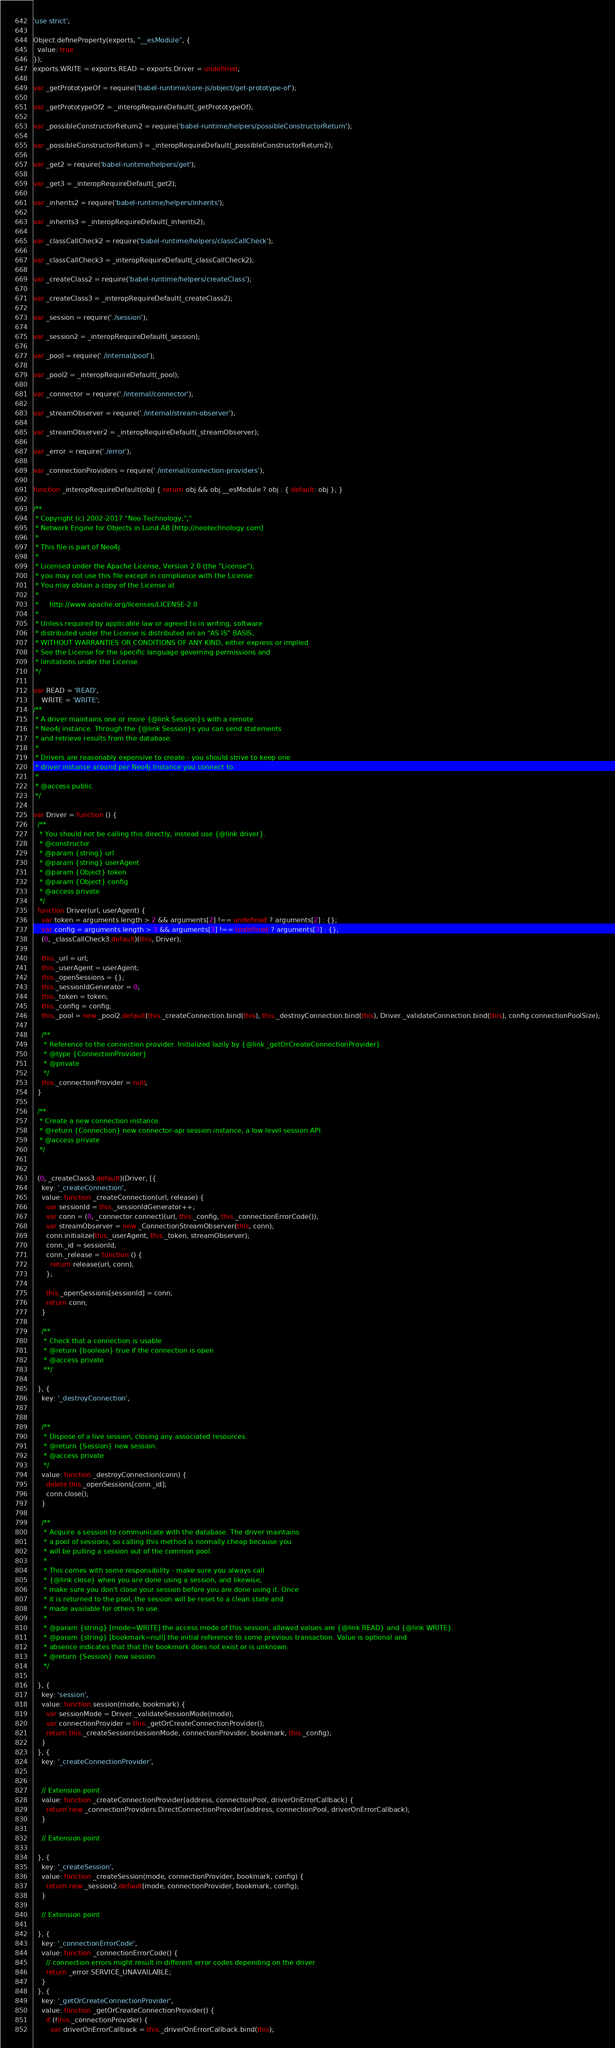Convert code to text. <code><loc_0><loc_0><loc_500><loc_500><_JavaScript_>'use strict';

Object.defineProperty(exports, "__esModule", {
  value: true
});
exports.WRITE = exports.READ = exports.Driver = undefined;

var _getPrototypeOf = require('babel-runtime/core-js/object/get-prototype-of');

var _getPrototypeOf2 = _interopRequireDefault(_getPrototypeOf);

var _possibleConstructorReturn2 = require('babel-runtime/helpers/possibleConstructorReturn');

var _possibleConstructorReturn3 = _interopRequireDefault(_possibleConstructorReturn2);

var _get2 = require('babel-runtime/helpers/get');

var _get3 = _interopRequireDefault(_get2);

var _inherits2 = require('babel-runtime/helpers/inherits');

var _inherits3 = _interopRequireDefault(_inherits2);

var _classCallCheck2 = require('babel-runtime/helpers/classCallCheck');

var _classCallCheck3 = _interopRequireDefault(_classCallCheck2);

var _createClass2 = require('babel-runtime/helpers/createClass');

var _createClass3 = _interopRequireDefault(_createClass2);

var _session = require('./session');

var _session2 = _interopRequireDefault(_session);

var _pool = require('./internal/pool');

var _pool2 = _interopRequireDefault(_pool);

var _connector = require('./internal/connector');

var _streamObserver = require('./internal/stream-observer');

var _streamObserver2 = _interopRequireDefault(_streamObserver);

var _error = require('./error');

var _connectionProviders = require('./internal/connection-providers');

function _interopRequireDefault(obj) { return obj && obj.__esModule ? obj : { default: obj }; }

/**
 * Copyright (c) 2002-2017 "Neo Technology,","
 * Network Engine for Objects in Lund AB [http://neotechnology.com]
 *
 * This file is part of Neo4j.
 *
 * Licensed under the Apache License, Version 2.0 (the "License");
 * you may not use this file except in compliance with the License.
 * You may obtain a copy of the License at
 *
 *     http://www.apache.org/licenses/LICENSE-2.0
 *
 * Unless required by applicable law or agreed to in writing, software
 * distributed under the License is distributed on an "AS IS" BASIS,
 * WITHOUT WARRANTIES OR CONDITIONS OF ANY KIND, either express or implied.
 * See the License for the specific language governing permissions and
 * limitations under the License.
 */

var READ = 'READ',
    WRITE = 'WRITE';
/**
 * A driver maintains one or more {@link Session}s with a remote
 * Neo4j instance. Through the {@link Session}s you can send statements
 * and retrieve results from the database.
 *
 * Drivers are reasonably expensive to create - you should strive to keep one
 * driver instance around per Neo4j Instance you connect to.
 *
 * @access public
 */

var Driver = function () {
  /**
   * You should not be calling this directly, instead use {@link driver}.
   * @constructor
   * @param {string} url
   * @param {string} userAgent
   * @param {Object} token
   * @param {Object} config
   * @access private
   */
  function Driver(url, userAgent) {
    var token = arguments.length > 2 && arguments[2] !== undefined ? arguments[2] : {};
    var config = arguments.length > 3 && arguments[3] !== undefined ? arguments[3] : {};
    (0, _classCallCheck3.default)(this, Driver);

    this._url = url;
    this._userAgent = userAgent;
    this._openSessions = {};
    this._sessionIdGenerator = 0;
    this._token = token;
    this._config = config;
    this._pool = new _pool2.default(this._createConnection.bind(this), this._destroyConnection.bind(this), Driver._validateConnection.bind(this), config.connectionPoolSize);

    /**
     * Reference to the connection provider. Initialized lazily by {@link _getOrCreateConnectionProvider}.
     * @type {ConnectionProvider}
     * @private
     */
    this._connectionProvider = null;
  }

  /**
   * Create a new connection instance.
   * @return {Connection} new connector-api session instance, a low level session API.
   * @access private
   */


  (0, _createClass3.default)(Driver, [{
    key: '_createConnection',
    value: function _createConnection(url, release) {
      var sessionId = this._sessionIdGenerator++;
      var conn = (0, _connector.connect)(url, this._config, this._connectionErrorCode());
      var streamObserver = new _ConnectionStreamObserver(this, conn);
      conn.initialize(this._userAgent, this._token, streamObserver);
      conn._id = sessionId;
      conn._release = function () {
        return release(url, conn);
      };

      this._openSessions[sessionId] = conn;
      return conn;
    }

    /**
     * Check that a connection is usable
     * @return {boolean} true if the connection is open
     * @access private
     **/

  }, {
    key: '_destroyConnection',


    /**
     * Dispose of a live session, closing any associated resources.
     * @return {Session} new session.
     * @access private
     */
    value: function _destroyConnection(conn) {
      delete this._openSessions[conn._id];
      conn.close();
    }

    /**
     * Acquire a session to communicate with the database. The driver maintains
     * a pool of sessions, so calling this method is normally cheap because you
     * will be pulling a session out of the common pool.
     *
     * This comes with some responsibility - make sure you always call
     * {@link close} when you are done using a session, and likewise,
     * make sure you don't close your session before you are done using it. Once
     * it is returned to the pool, the session will be reset to a clean state and
     * made available for others to use.
     *
     * @param {string} [mode=WRITE] the access mode of this session, allowed values are {@link READ} and {@link WRITE}.
     * @param {string} [bookmark=null] the initial reference to some previous transaction. Value is optional and
     * absence indicates that that the bookmark does not exist or is unknown.
     * @return {Session} new session.
     */

  }, {
    key: 'session',
    value: function session(mode, bookmark) {
      var sessionMode = Driver._validateSessionMode(mode);
      var connectionProvider = this._getOrCreateConnectionProvider();
      return this._createSession(sessionMode, connectionProvider, bookmark, this._config);
    }
  }, {
    key: '_createConnectionProvider',


    // Extension point
    value: function _createConnectionProvider(address, connectionPool, driverOnErrorCallback) {
      return new _connectionProviders.DirectConnectionProvider(address, connectionPool, driverOnErrorCallback);
    }

    // Extension point

  }, {
    key: '_createSession',
    value: function _createSession(mode, connectionProvider, bookmark, config) {
      return new _session2.default(mode, connectionProvider, bookmark, config);
    }

    // Extension point

  }, {
    key: '_connectionErrorCode',
    value: function _connectionErrorCode() {
      // connection errors might result in different error codes depending on the driver
      return _error.SERVICE_UNAVAILABLE;
    }
  }, {
    key: '_getOrCreateConnectionProvider',
    value: function _getOrCreateConnectionProvider() {
      if (!this._connectionProvider) {
        var driverOnErrorCallback = this._driverOnErrorCallback.bind(this);</code> 